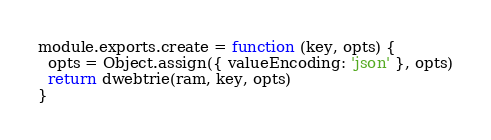Convert code to text. <code><loc_0><loc_0><loc_500><loc_500><_JavaScript_>
module.exports.create = function (key, opts) {
  opts = Object.assign({ valueEncoding: 'json' }, opts)
  return dwebtrie(ram, key, opts)
}
</code> 